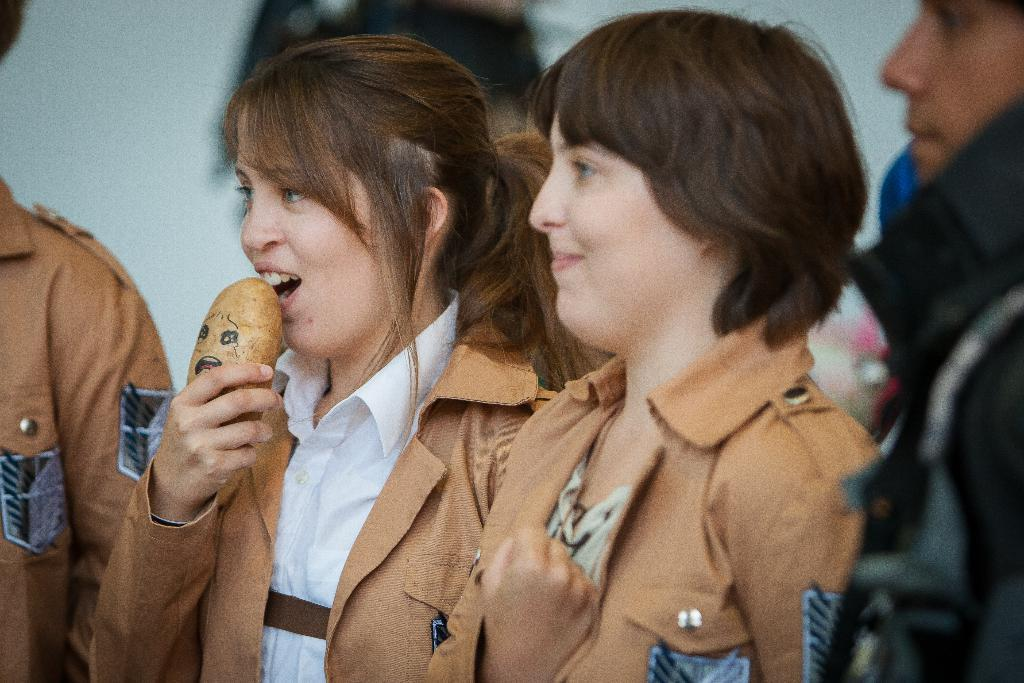What can be seen in the image? There is a group of people in the image. What colors are the people wearing? The people are wearing black, white, and brown color dresses. Can you describe any specific actions or objects in the image? One person is holding a brown object. What is the appearance of the background in the image? The background of the image is blurred. How many people are standing on the board in the image? There is no board present in the image, so it is not possible to answer that question. 